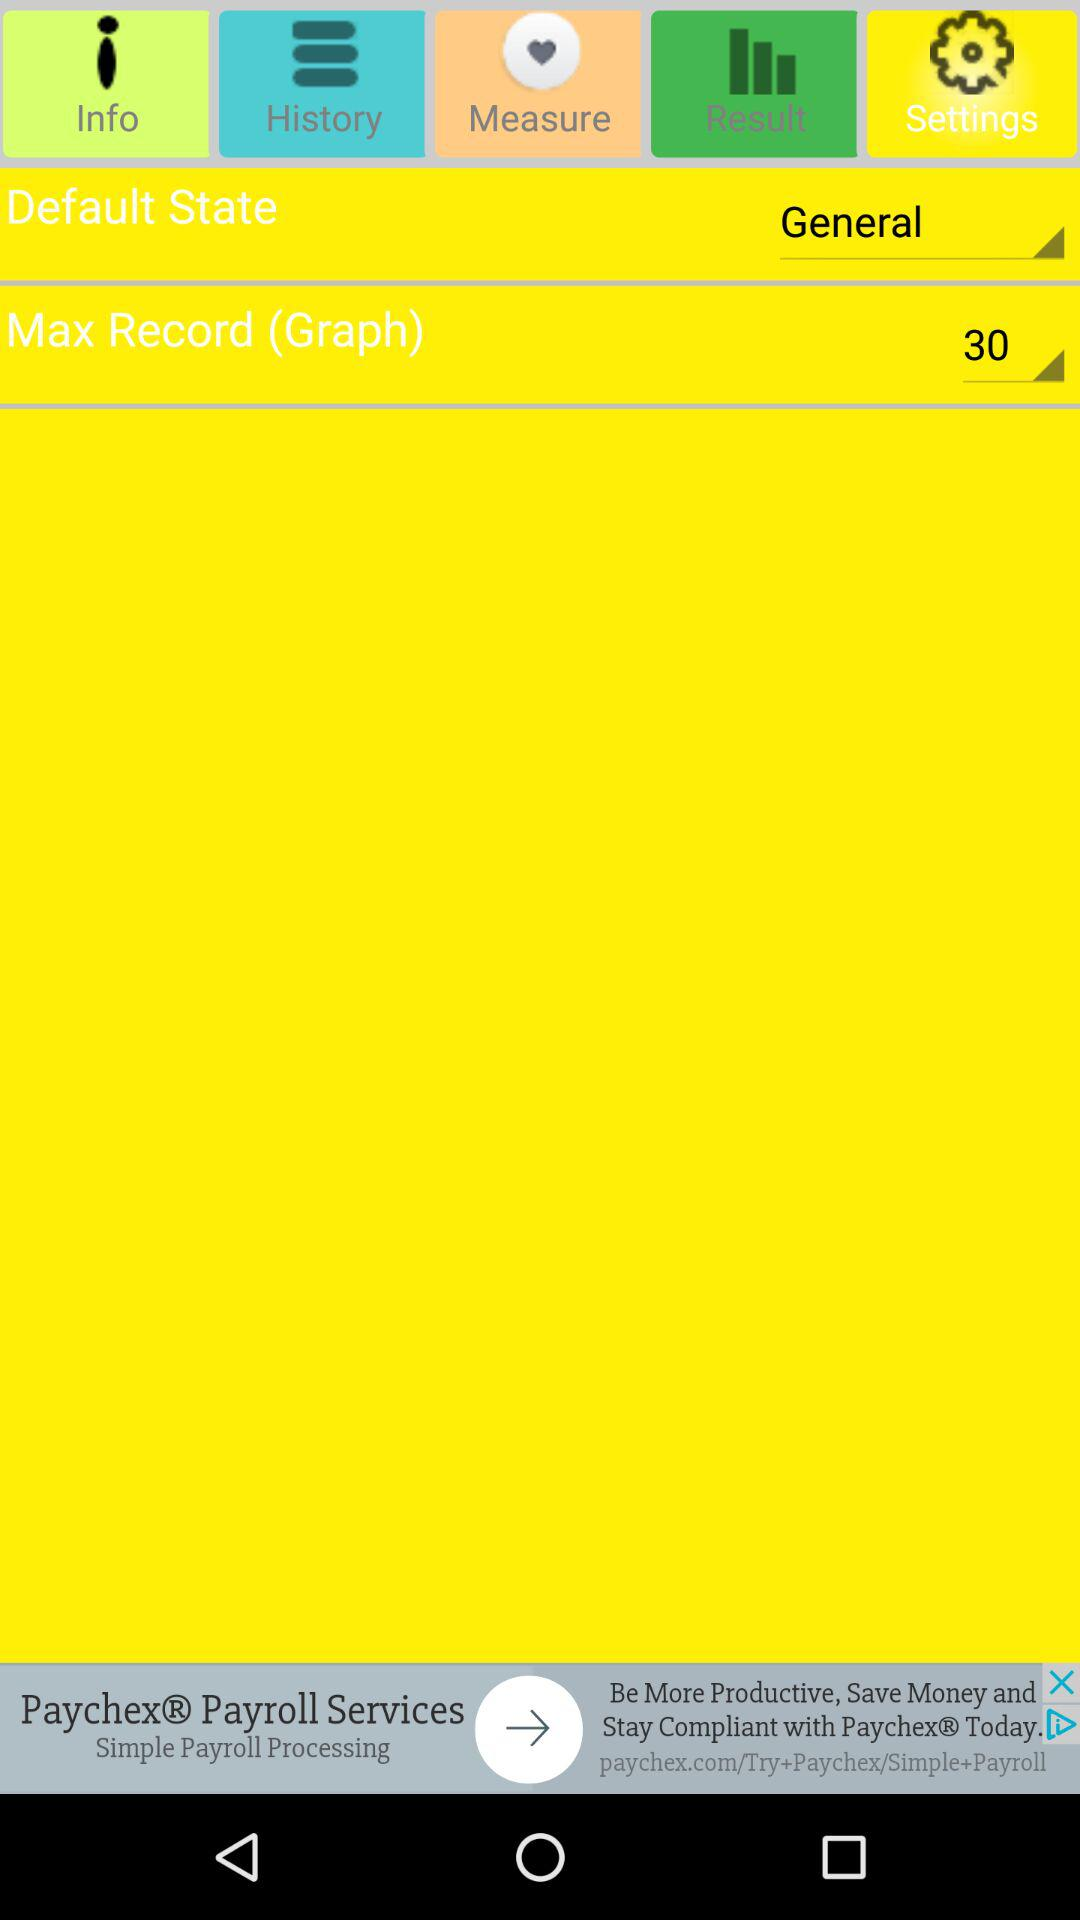What is the maximum record? The selected value is 30. 